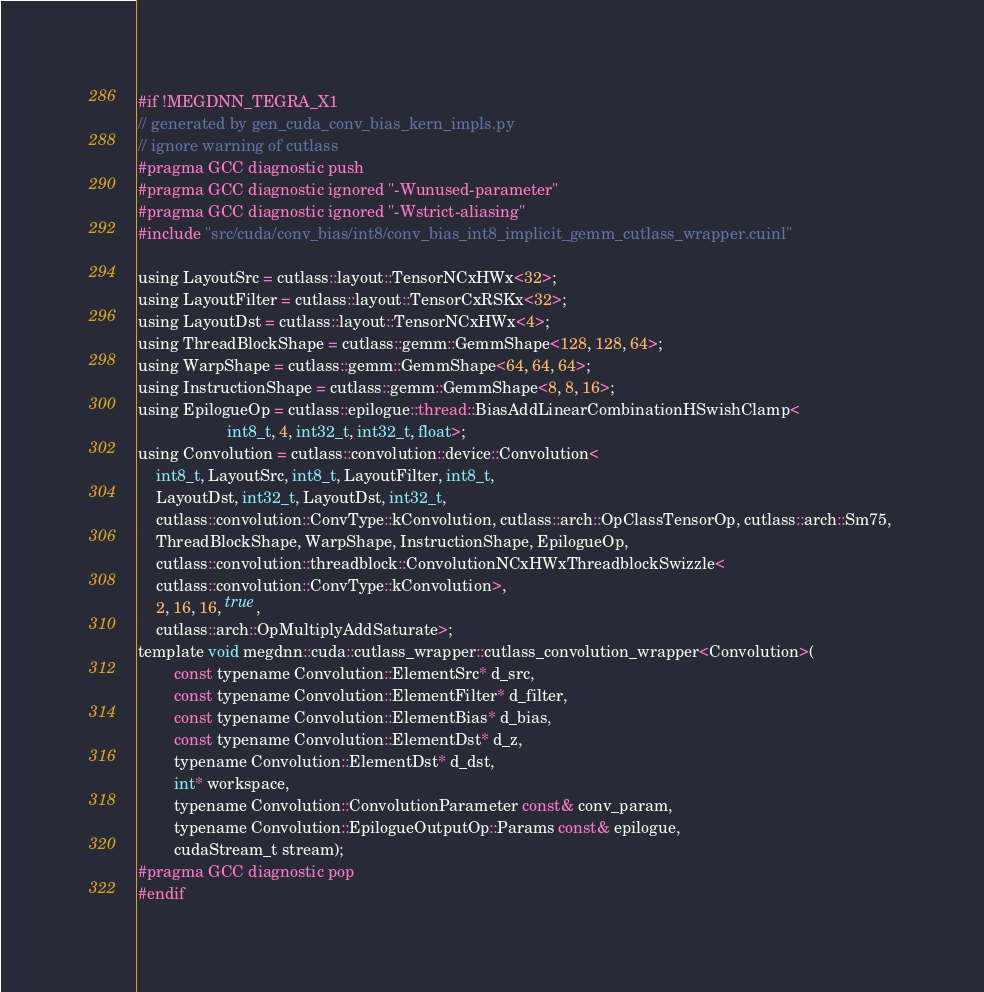<code> <loc_0><loc_0><loc_500><loc_500><_Cuda_>#if !MEGDNN_TEGRA_X1
// generated by gen_cuda_conv_bias_kern_impls.py
// ignore warning of cutlass
#pragma GCC diagnostic push
#pragma GCC diagnostic ignored "-Wunused-parameter"
#pragma GCC diagnostic ignored "-Wstrict-aliasing"
#include "src/cuda/conv_bias/int8/conv_bias_int8_implicit_gemm_cutlass_wrapper.cuinl"

using LayoutSrc = cutlass::layout::TensorNCxHWx<32>;
using LayoutFilter = cutlass::layout::TensorCxRSKx<32>;
using LayoutDst = cutlass::layout::TensorNCxHWx<4>;
using ThreadBlockShape = cutlass::gemm::GemmShape<128, 128, 64>;
using WarpShape = cutlass::gemm::GemmShape<64, 64, 64>;
using InstructionShape = cutlass::gemm::GemmShape<8, 8, 16>;
using EpilogueOp = cutlass::epilogue::thread::BiasAddLinearCombinationHSwishClamp<
                    int8_t, 4, int32_t, int32_t, float>;
using Convolution = cutlass::convolution::device::Convolution<
    int8_t, LayoutSrc, int8_t, LayoutFilter, int8_t, 
    LayoutDst, int32_t, LayoutDst, int32_t, 
    cutlass::convolution::ConvType::kConvolution, cutlass::arch::OpClassTensorOp, cutlass::arch::Sm75, 
    ThreadBlockShape, WarpShape, InstructionShape, EpilogueOp, 
    cutlass::convolution::threadblock::ConvolutionNCxHWxThreadblockSwizzle<
    cutlass::convolution::ConvType::kConvolution>, 
    2, 16, 16, true, 
    cutlass::arch::OpMultiplyAddSaturate>;
template void megdnn::cuda::cutlass_wrapper::cutlass_convolution_wrapper<Convolution>(
        const typename Convolution::ElementSrc* d_src, 
        const typename Convolution::ElementFilter* d_filter, 
        const typename Convolution::ElementBias* d_bias, 
        const typename Convolution::ElementDst* d_z, 
        typename Convolution::ElementDst* d_dst, 
        int* workspace, 
        typename Convolution::ConvolutionParameter const& conv_param, 
        typename Convolution::EpilogueOutputOp::Params const& epilogue, 
        cudaStream_t stream);
#pragma GCC diagnostic pop
#endif
</code> 